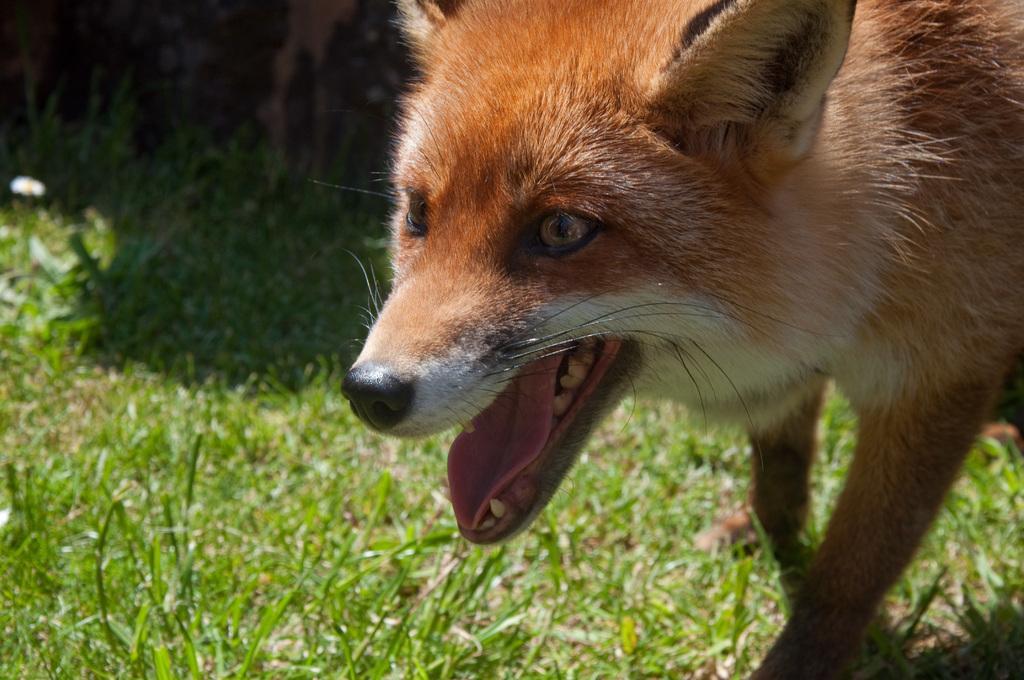How would you summarize this image in a sentence or two? In this image we can see there is a animal and grass. 